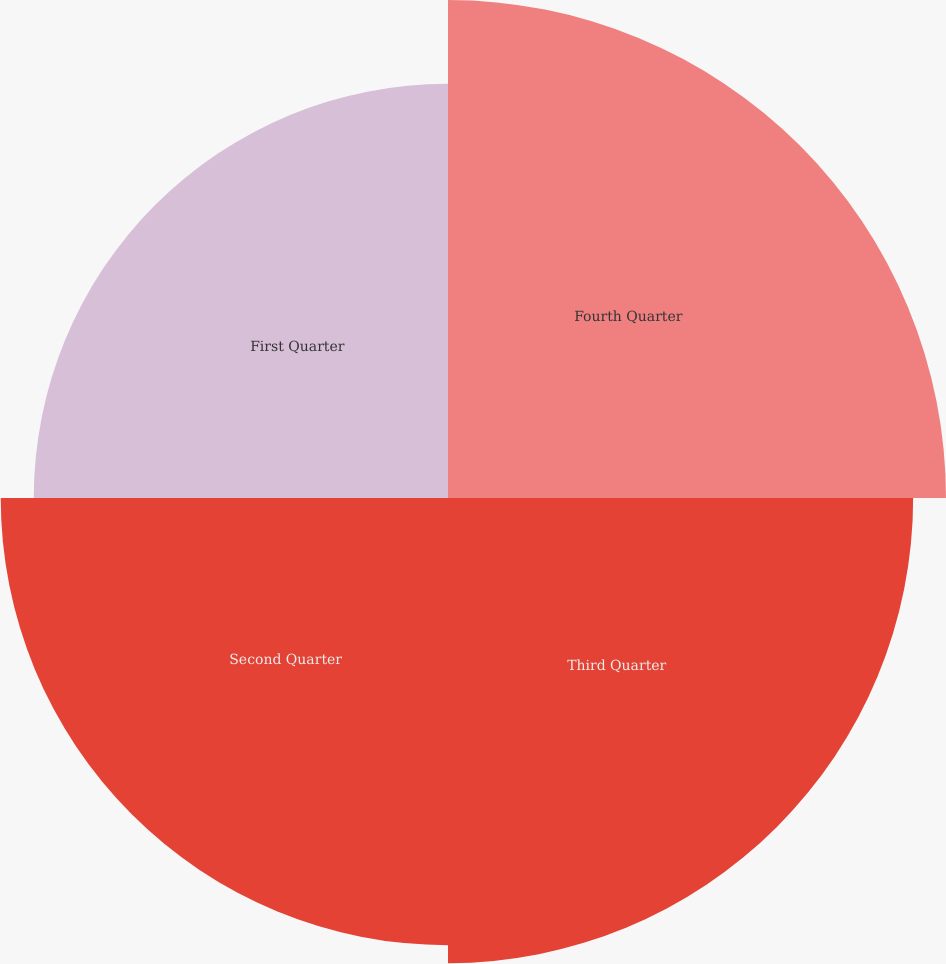<chart> <loc_0><loc_0><loc_500><loc_500><pie_chart><fcel>Fourth Quarter<fcel>Third Quarter<fcel>Second Quarter<fcel>First Quarter<nl><fcel>27.29%<fcel>25.49%<fcel>24.51%<fcel>22.7%<nl></chart> 